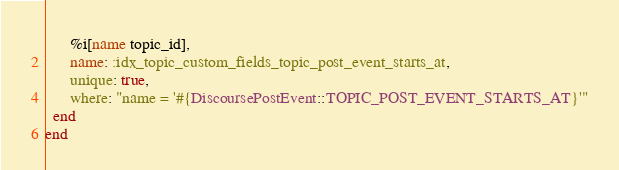<code> <loc_0><loc_0><loc_500><loc_500><_Ruby_>      %i[name topic_id],
      name: :idx_topic_custom_fields_topic_post_event_starts_at,
      unique: true,
      where: "name = '#{DiscoursePostEvent::TOPIC_POST_EVENT_STARTS_AT}'"
  end
end
</code> 